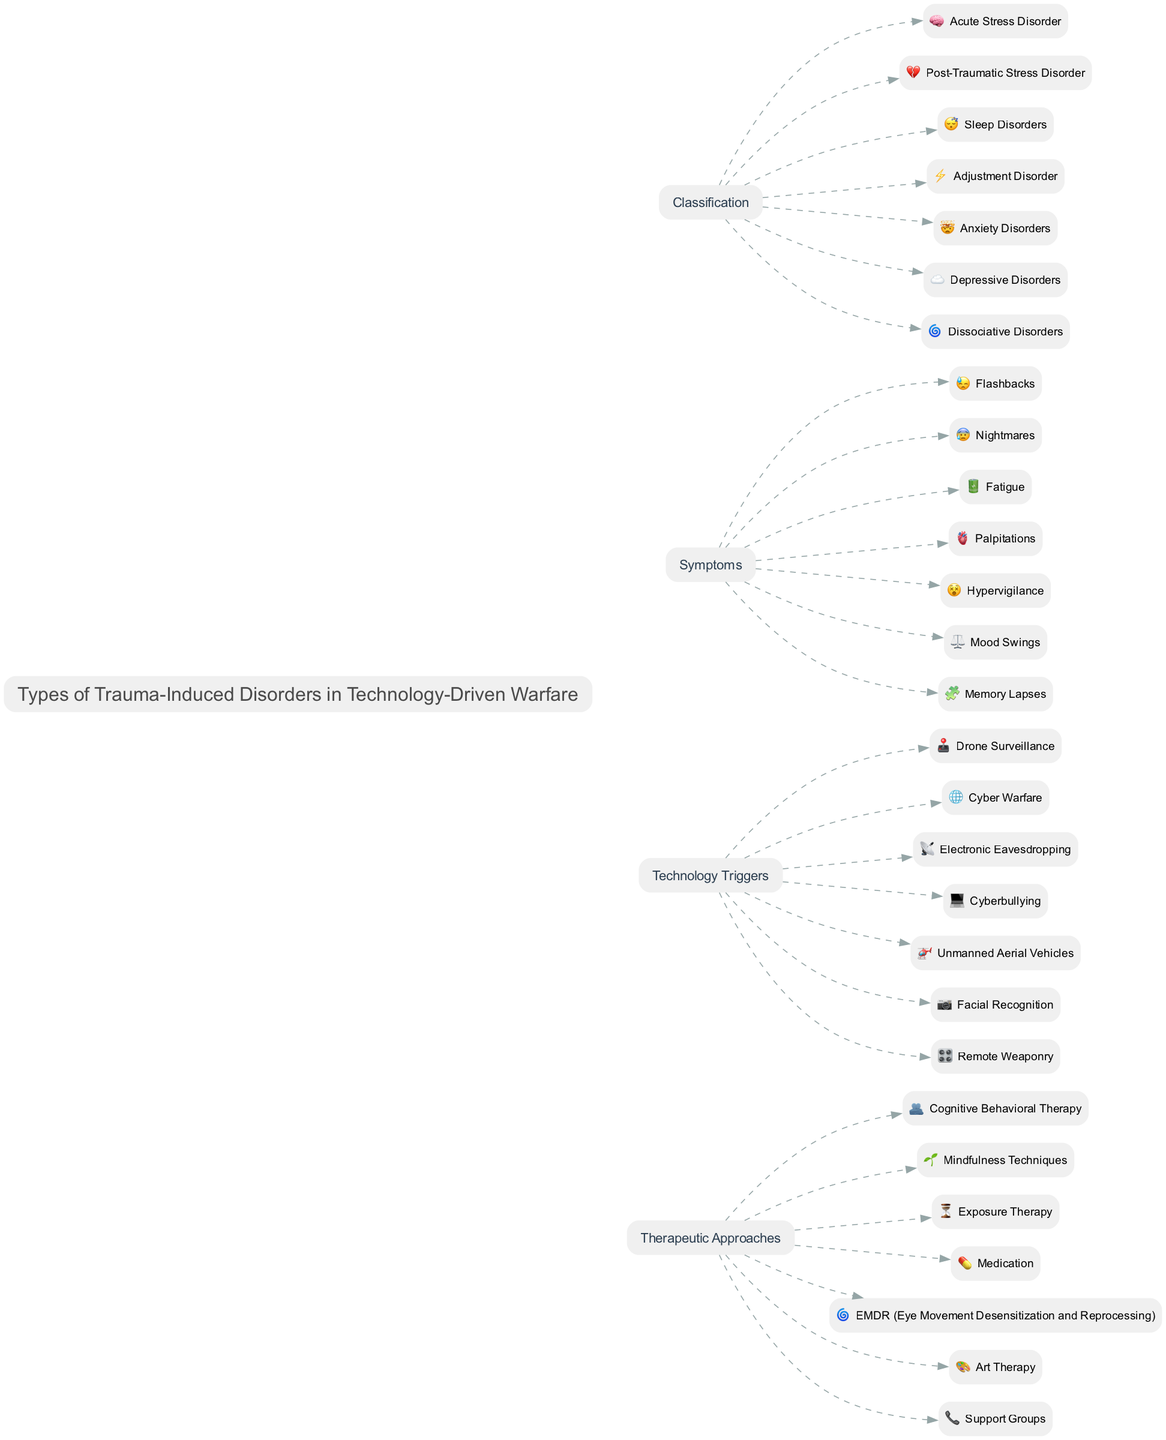What is the title of the diagram? The title node in the diagram contains the text "Types of Trauma-Induced Disorders in Technology-Driven Warfare." This is the main title displayed prominently at the top of the diagram.
Answer: Types of Trauma-Induced Disorders in Technology-Driven Warfare How many types of trauma-induced disorders are listed? By counting the nodes in the "Classification" column, there are seven distinct types of trauma-induced disorders listed.
Answer: 7 Which symptom is associated with Post-Traumatic Stress Disorder? Looking at the "Symptoms" column, "Flashbacks" is indicated as a symptom related to Post-Traumatic Stress Disorder, as it is visually connected to that classification.
Answer: Flashbacks What technology trigger is linked with Anxiety Disorders? To find the technology trigger linked to Anxiety Disorders, one must see the "Technology Triggers" column and the connection with the "Anxiety Disorders" classification. "Cyberbullying" is noted as the trigger for this disorder.
Answer: Cyberbullying What therapeutic approach is suggested for Dissociative Disorders? By examining the "Therapeutic Approaches" column, we locate the connection to Dissociative Disorders. The recommended therapeutic approach listed is "EMDR (Eye Movement Desensitization and Reprocessing)," specifically indicated for this disorder.
Answer: EMDR (Eye Movement Desensitization and Reprocessing) Which symptoms are associated with Sleep Disorders? In the "Symptoms" column, fatigue and nightmares are visible. By cross-referencing with the "Classification" column, both these symptoms can be attributed to Sleep Disorders. Hence, two symptoms are associated with this condition.
Answer: Fatigue and Nightmares What is the common technology trigger for both Acute Stress Disorder and Adjustment Disorder? Analyzing the technology triggers for these two disorders in the context of their respective nodes shows that "Drone Surveillance" serves as the common trigger for both Acute Stress Disorder and Adjustment Disorder.
Answer: Drone Surveillance Which therapeutic approach is most commonly recommended across all disorders? Evaluating the "Therapeutic Approaches" column indicates that "Cognitive Behavioral Therapy" is mentioned, showing its significance in managing various types of trauma-induced disorders.
Answer: Cognitive Behavioral Therapy How many symptoms are listed for Anxiety Disorders? Upon reviewing the "Symptoms" column, there are a total of six symptoms, but specifically, Anxiety Disorders are associated with "Hypervigilance." This requires identifying whether there are more symptoms directly therein but the visual indicates primarily this singular association.
Answer: Hypervigilance 